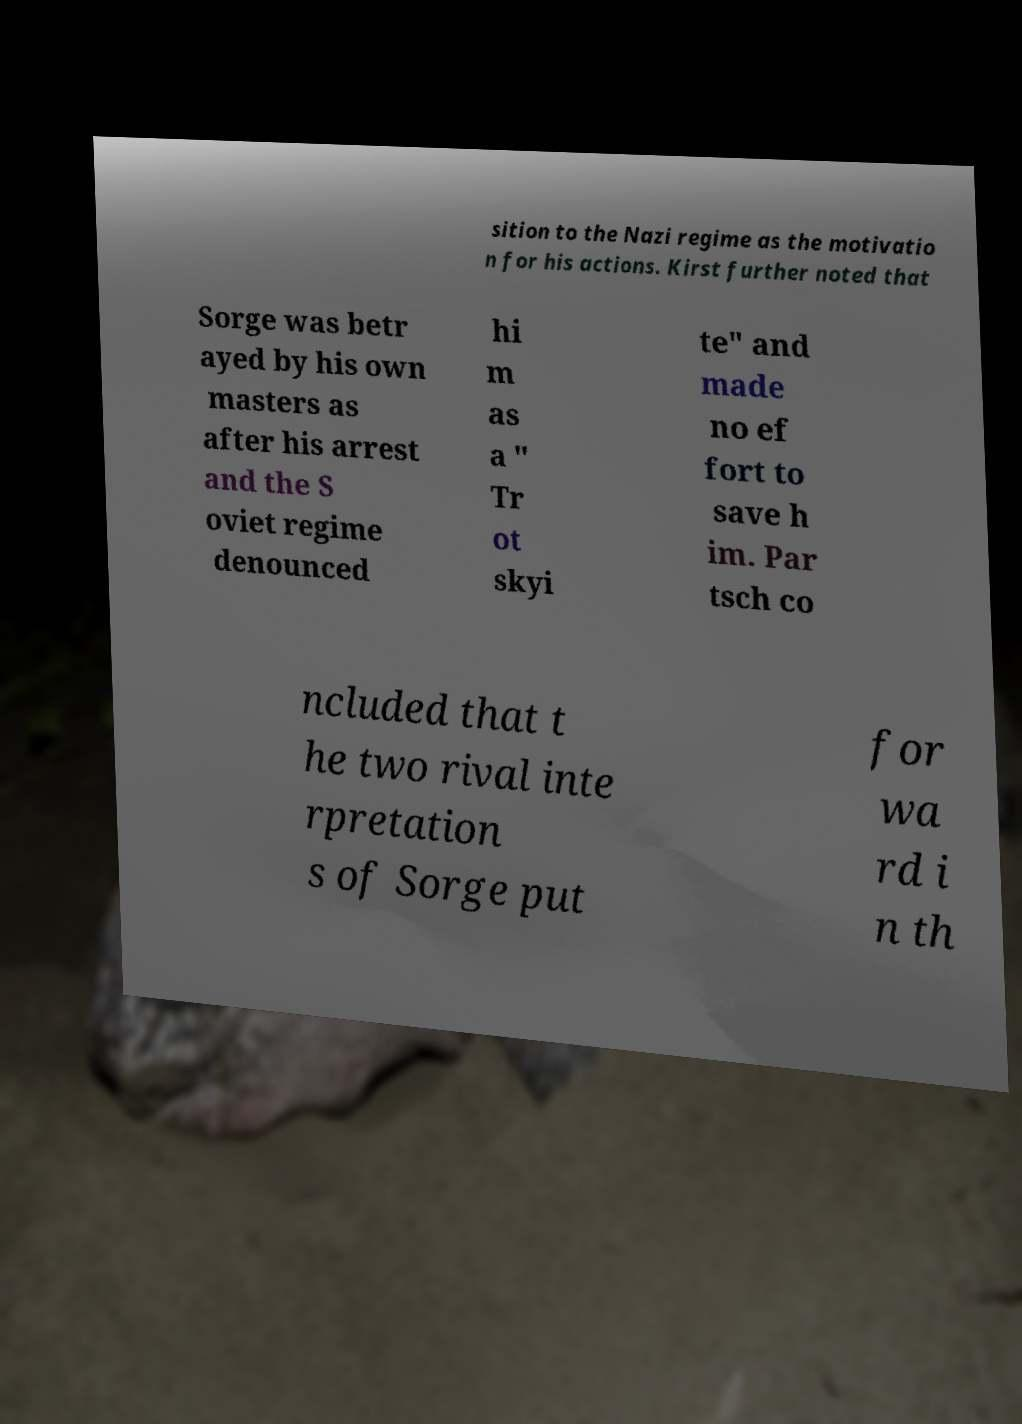What messages or text are displayed in this image? I need them in a readable, typed format. sition to the Nazi regime as the motivatio n for his actions. Kirst further noted that Sorge was betr ayed by his own masters as after his arrest and the S oviet regime denounced hi m as a " Tr ot skyi te" and made no ef fort to save h im. Par tsch co ncluded that t he two rival inte rpretation s of Sorge put for wa rd i n th 